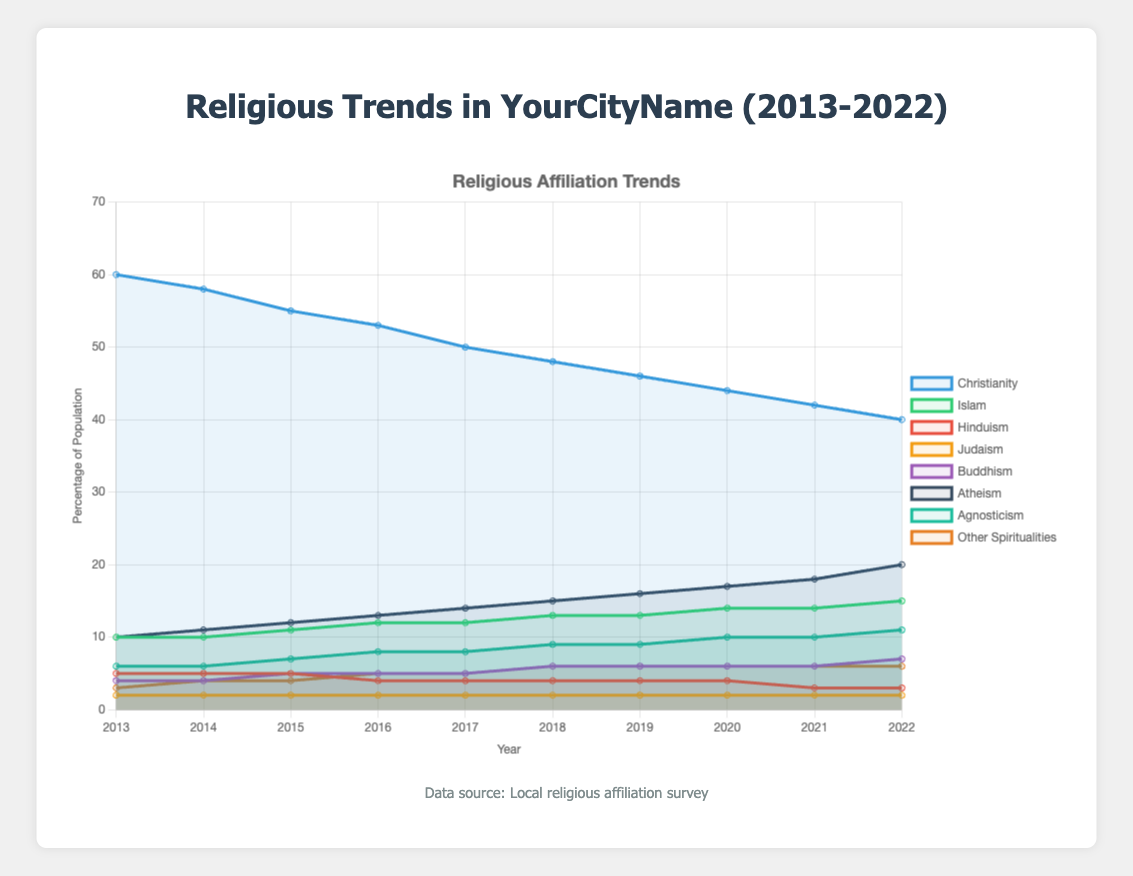What trend is observed in the percentage of people identifying with Christianity from 2013 to 2022? Observing the line for Christianity, it shows a consistent decline over the years from 60% in 2013 to 40% in 2022.
Answer: Declining trend Compare the percentage change in people identifying as Atheist to those identifying as Muslim from 2013 to 2022. For Atheism, the percentage increased from 10% to 20% (a 10% increase). For Islam, the percentage rose from 10% to 15% (a 5% increase). Thus, Atheism saw a higher percentage change than Islam.
Answer: Atheism had a higher increase What is the total percentage of Non-Religious Identifications (Atheism, Agnosticism, Other Spiritualities) in 2022? Summing the percentages in Non-Religious Identifications for 2022: Atheism (20%) + Agnosticism (11%) + Other Spiritualities (6%) equals 37%.
Answer: 37% Which religious affiliation had the least change in its percentage from 2013 to 2022? Judaism remained constant at 2% throughout the period from 2013 to 2022, indicating no change.
Answer: Judaism By how much did the percentage of people identifying with Buddhism increase from 2013 to 2022? In 2013, the percentage of Buddhists was 4%. By 2022, it increased to 7%. The change is 7% - 4% = 3%.
Answer: 3% What is the average percentage identification with Islam over the given period? The percentages for Islam over the years are 10%, 10%, 11%, 12%, 12%, 13%, 13%, 14%, 14%, and 15%. Summing them gives 124, and the average is 124 / 10 = 12.4%.
Answer: 12.4% Which group has the highest percentage in 2022? Referring to the plot, Christianity has the highest percentage (40%) in 2022 among all other affiliations and identifications.
Answer: Christianity What was the percentage point difference in Agnosticism between 2014 and 2018? In 2014, Agnosticism was at 6%, and in 2018, it was at 9%. The difference is 9% - 6% = 3%.
Answer: 3% What is the sum of the percentages of people identifying with Hinduism, Judaism, and Buddhism in 2016? In 2016, the percentages are Hinduism (4%), Judaism (2%), and Buddhism (5%). Summing these gives 4% + 2% + 5% = 11%.
Answer: 11% Which line represents the most rapid increase in non-religious identifications over the decade? Examining the steepness of the lines, Atheism shows the fastest consistent increase, rising from 10% to 20% over the decade.
Answer: Atheism 